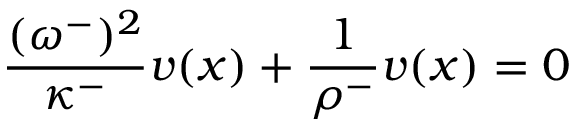<formula> <loc_0><loc_0><loc_500><loc_500>\frac { ( \omega ^ { - } ) ^ { 2 } } { \kappa ^ { - } } v ( x ) + \frac { 1 } { \rho ^ { - } } v ( x ) = 0</formula> 